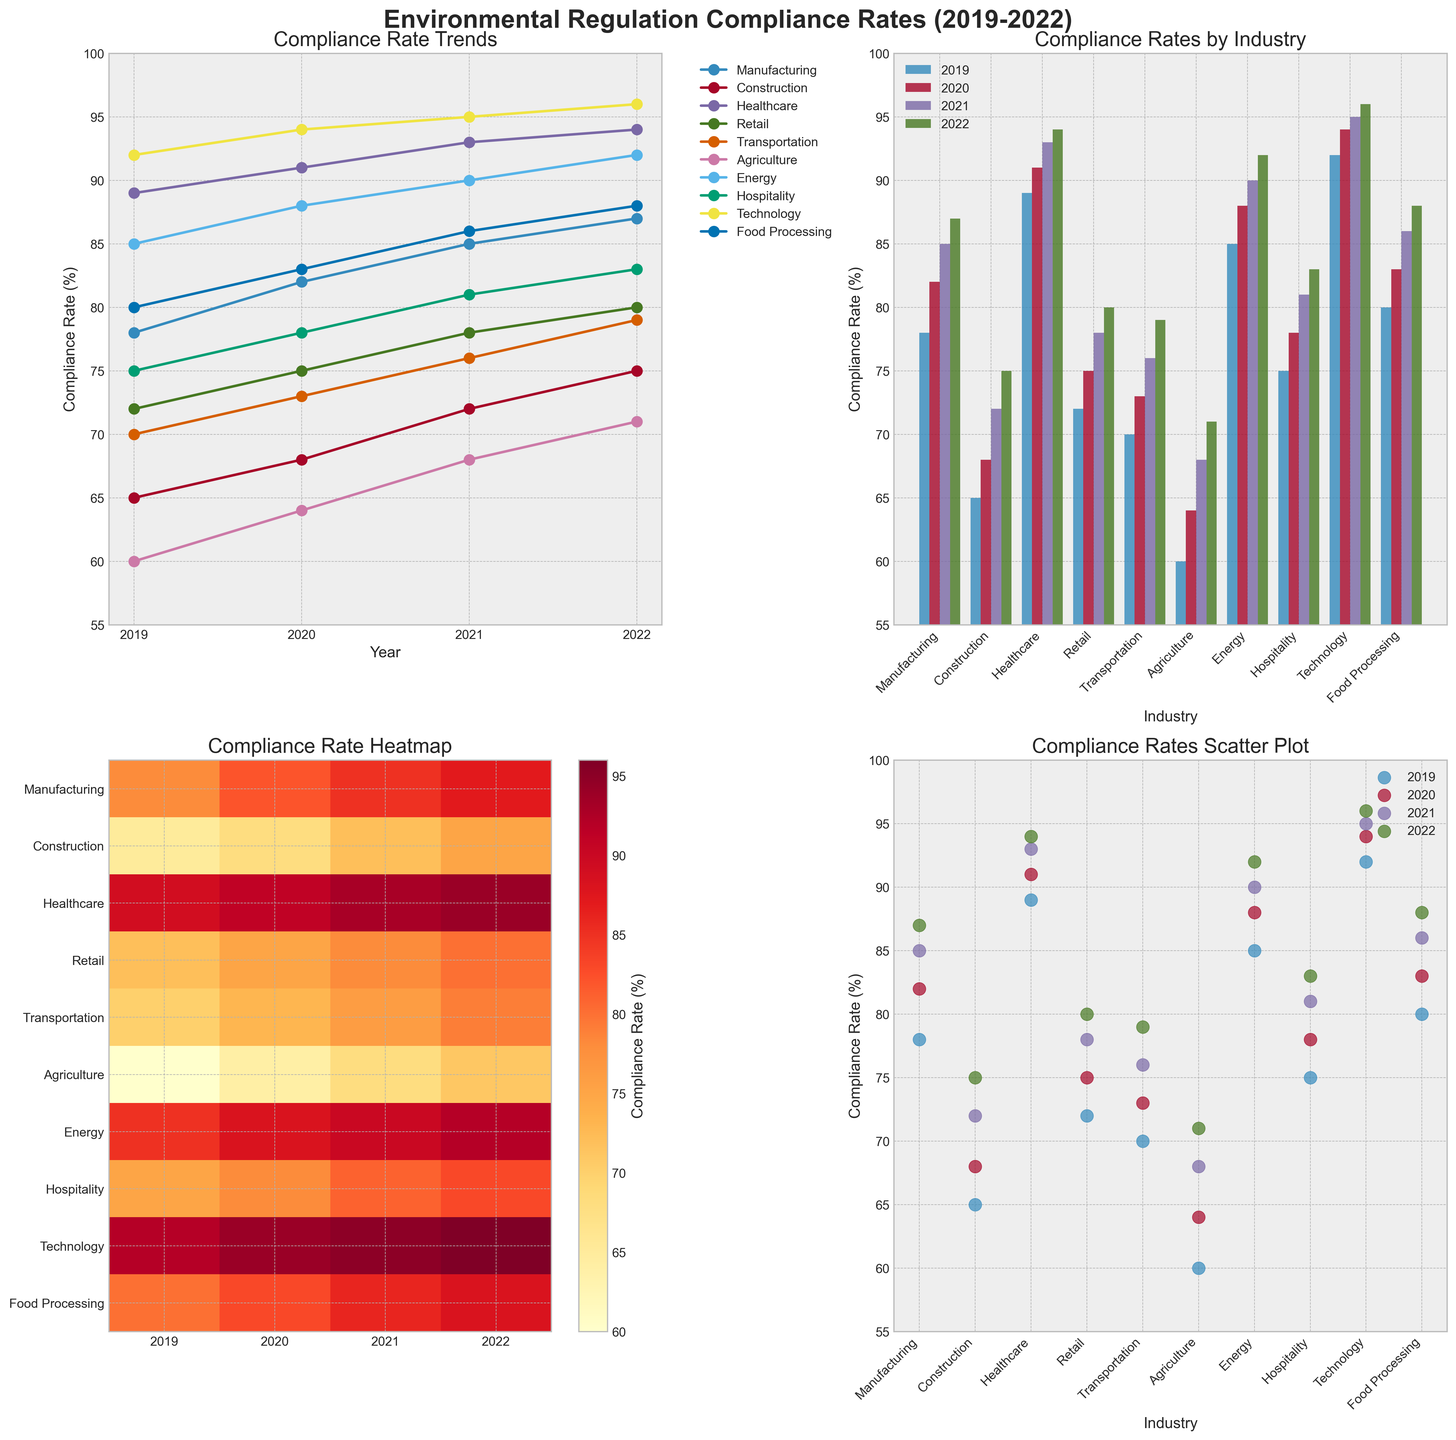What is the title of the line plot? The title for the line plot can be seen at the top of the first subplot in the grid.
Answer: Compliance Rate Trends Which industry had the highest compliance rate in 2022 according to the scatter plot? In the scatter plot, the 2022 data points should be checked to find the industry with the highest compliance rate.
Answer: Technology What is the difference in compliance rates between the Construction and Healthcare industries in 2022 as seen in the bar plot? Check the bar heights for Construction and Healthcare in the 2022 section and calculate the difference: 94 (Healthcare) - 75 (Construction) = 19.
Answer: 19 Which industry shows the highest increase in compliance rate from 2019 to 2022 as per the line plot? Observe the lines in the line plot and measure from 2019 to 2022. The Healthcare industry line has the steepest increase: 94 (2022) - 89 (2019) = 5.
Answer: Healthcare How many industries have a compliance rate above 80% in 2021 based on the heatmap? Count the cells in the 2021 column of the heatmap that are darker shades, indicating values above 80%.
Answer: 6 Which years are displayed on the x-axis of the heatmap? The x-axis labels of the heatmap can be directly read.
Answer: 2019, 2020, 2021, 2022 From the scatter plot, which industry had the lowest compliance rate in 2019? By visually inspecting the scatter plot for the 2019 data points, the industry with the lowest point is Agriculture with 60%.
Answer: Agriculture According to the bar plot, what is the average compliance rate of the Retail industry over the four years? Identify the four bars for Retail in the bar plot (75, 78, 80) and calculate the average: (72+75+78+80)/4 = 76.25.
Answer: 76.25 In the line plot, which industry's compliance rate remained constant throughout 2020 and 2021? Look for lines where the 2020 and 2021 markers are at the same height. The Technology industry shows such a trend (94%).
Answer: Technology 